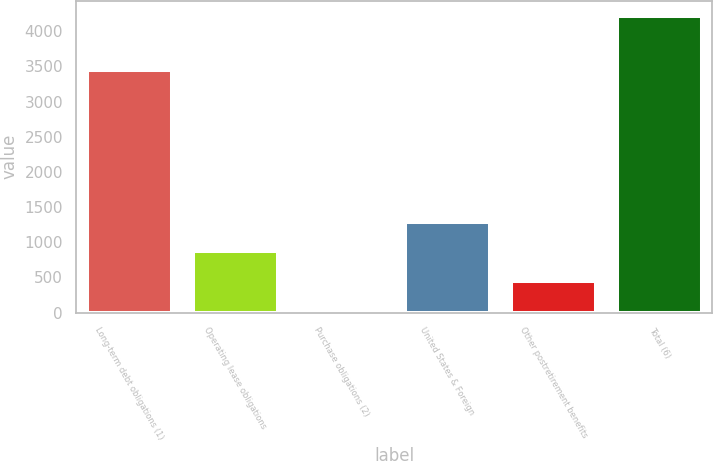Convert chart. <chart><loc_0><loc_0><loc_500><loc_500><bar_chart><fcel>Long-term debt obligations (1)<fcel>Operating lease obligations<fcel>Purchase obligations (2)<fcel>United States & Foreign<fcel>Other postretirement benefits<fcel>Total (6)<nl><fcel>3447<fcel>872.8<fcel>35<fcel>1291.7<fcel>453.9<fcel>4224<nl></chart> 